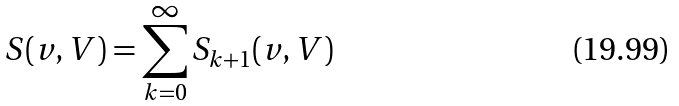<formula> <loc_0><loc_0><loc_500><loc_500>S ( v , V ) = \sum _ { k = 0 } ^ { \infty } S _ { k + 1 } ( v , V )</formula> 